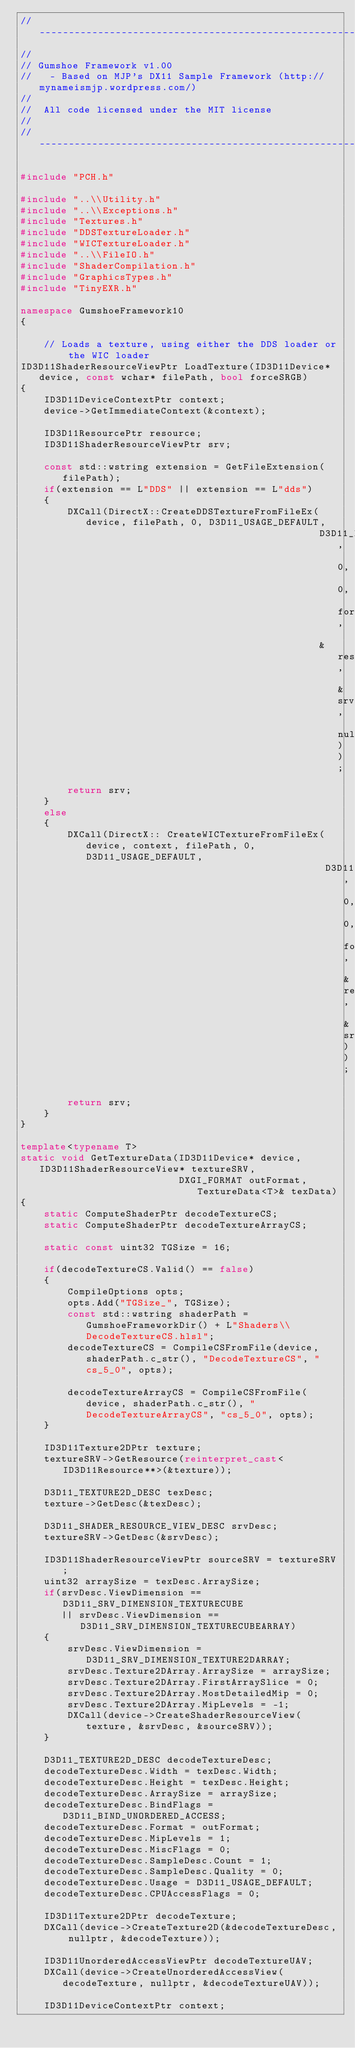<code> <loc_0><loc_0><loc_500><loc_500><_C++_>//-------------------------------------------------------------------------------
//
// Gumshoe Framework v1.00
//   - Based on MJP's DX11 Sample Framework (http://mynameismjp.wordpress.com/)
//
//  All code licensed under the MIT license
//
//-------------------------------------------------------------------------------

#include "PCH.h"

#include "..\\Utility.h"
#include "..\\Exceptions.h"
#include "Textures.h"
#include "DDSTextureLoader.h"
#include "WICTextureLoader.h"
#include "..\\FileIO.h"
#include "ShaderCompilation.h"
#include "GraphicsTypes.h"
#include "TinyEXR.h"

namespace GumshoeFramework10
{

    // Loads a texture, using either the DDS loader or the WIC loader
ID3D11ShaderResourceViewPtr LoadTexture(ID3D11Device* device, const wchar* filePath, bool forceSRGB)
{
    ID3D11DeviceContextPtr context;
    device->GetImmediateContext(&context);

    ID3D11ResourcePtr resource;
    ID3D11ShaderResourceViewPtr srv;

    const std::wstring extension = GetFileExtension(filePath);
    if(extension == L"DDS" || extension == L"dds")
    {
        DXCall(DirectX::CreateDDSTextureFromFileEx(device, filePath, 0, D3D11_USAGE_DEFAULT,
                                                   D3D11_BIND_SHADER_RESOURCE, 0, 0, forceSRGB,
                                                   &resource, &srv, nullptr));
        return srv;
    }
    else
    {
        DXCall(DirectX:: CreateWICTextureFromFileEx(device, context, filePath, 0, D3D11_USAGE_DEFAULT,
                                                    D3D11_BIND_SHADER_RESOURCE, 0, 0, forceSRGB, &resource, &srv));

        return srv;
    }
}

template<typename T>
static void GetTextureData(ID3D11Device* device, ID3D11ShaderResourceView* textureSRV,
                           DXGI_FORMAT outFormat, TextureData<T>& texData)
{
    static ComputeShaderPtr decodeTextureCS;
    static ComputeShaderPtr decodeTextureArrayCS;

    static const uint32 TGSize = 16;

    if(decodeTextureCS.Valid() == false)
    {
        CompileOptions opts;
        opts.Add("TGSize_", TGSize);
        const std::wstring shaderPath = GumshoeFrameworkDir() + L"Shaders\\DecodeTextureCS.hlsl";
        decodeTextureCS = CompileCSFromFile(device, shaderPath.c_str(), "DecodeTextureCS", "cs_5_0", opts);

        decodeTextureArrayCS = CompileCSFromFile(device, shaderPath.c_str(), "DecodeTextureArrayCS", "cs_5_0", opts);
    }

    ID3D11Texture2DPtr texture;
    textureSRV->GetResource(reinterpret_cast<ID3D11Resource**>(&texture));

    D3D11_TEXTURE2D_DESC texDesc;
    texture->GetDesc(&texDesc);

    D3D11_SHADER_RESOURCE_VIEW_DESC srvDesc;
    textureSRV->GetDesc(&srvDesc);

    ID3D11ShaderResourceViewPtr sourceSRV = textureSRV;
    uint32 arraySize = texDesc.ArraySize;
    if(srvDesc.ViewDimension == D3D11_SRV_DIMENSION_TEXTURECUBE
       || srvDesc.ViewDimension == D3D11_SRV_DIMENSION_TEXTURECUBEARRAY)
    {
        srvDesc.ViewDimension = D3D11_SRV_DIMENSION_TEXTURE2DARRAY;
        srvDesc.Texture2DArray.ArraySize = arraySize;
        srvDesc.Texture2DArray.FirstArraySlice = 0;
        srvDesc.Texture2DArray.MostDetailedMip = 0;
        srvDesc.Texture2DArray.MipLevels = -1;
        DXCall(device->CreateShaderResourceView(texture, &srvDesc, &sourceSRV));
    }

    D3D11_TEXTURE2D_DESC decodeTextureDesc;
    decodeTextureDesc.Width = texDesc.Width;
    decodeTextureDesc.Height = texDesc.Height;
    decodeTextureDesc.ArraySize = arraySize;
    decodeTextureDesc.BindFlags = D3D11_BIND_UNORDERED_ACCESS;
    decodeTextureDesc.Format = outFormat;
    decodeTextureDesc.MipLevels = 1;
    decodeTextureDesc.MiscFlags = 0;
    decodeTextureDesc.SampleDesc.Count = 1;
    decodeTextureDesc.SampleDesc.Quality = 0;
    decodeTextureDesc.Usage = D3D11_USAGE_DEFAULT;
    decodeTextureDesc.CPUAccessFlags = 0;

    ID3D11Texture2DPtr decodeTexture;
    DXCall(device->CreateTexture2D(&decodeTextureDesc, nullptr, &decodeTexture));

    ID3D11UnorderedAccessViewPtr decodeTextureUAV;
    DXCall(device->CreateUnorderedAccessView(decodeTexture, nullptr, &decodeTextureUAV));

    ID3D11DeviceContextPtr context;</code> 